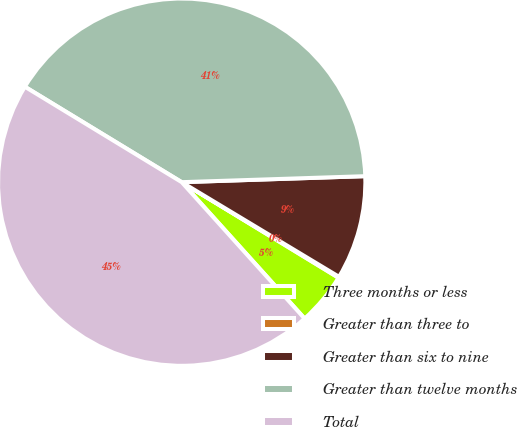Convert chart. <chart><loc_0><loc_0><loc_500><loc_500><pie_chart><fcel>Three months or less<fcel>Greater than three to<fcel>Greater than six to nine<fcel>Greater than twelve months<fcel>Total<nl><fcel>4.62%<fcel>0.09%<fcel>9.14%<fcel>40.78%<fcel>45.37%<nl></chart> 